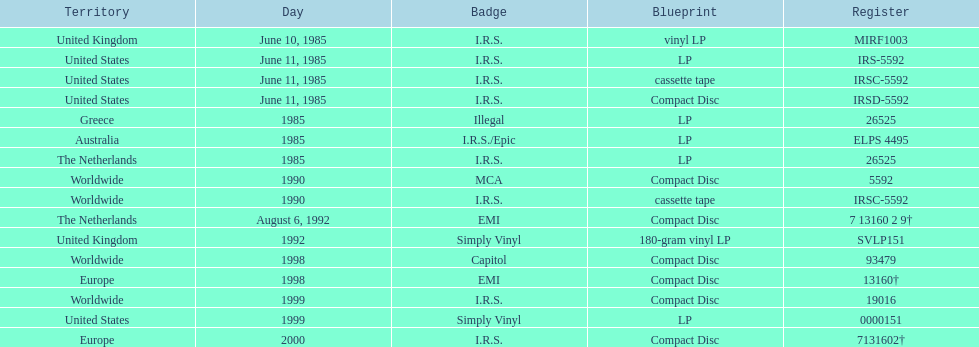Which is the only region with vinyl lp format? United Kingdom. Can you give me this table as a dict? {'header': ['Territory', 'Day', 'Badge', 'Blueprint', 'Register'], 'rows': [['United Kingdom', 'June 10, 1985', 'I.R.S.', 'vinyl LP', 'MIRF1003'], ['United States', 'June 11, 1985', 'I.R.S.', 'LP', 'IRS-5592'], ['United States', 'June 11, 1985', 'I.R.S.', 'cassette tape', 'IRSC-5592'], ['United States', 'June 11, 1985', 'I.R.S.', 'Compact Disc', 'IRSD-5592'], ['Greece', '1985', 'Illegal', 'LP', '26525'], ['Australia', '1985', 'I.R.S./Epic', 'LP', 'ELPS 4495'], ['The Netherlands', '1985', 'I.R.S.', 'LP', '26525'], ['Worldwide', '1990', 'MCA', 'Compact Disc', '5592'], ['Worldwide', '1990', 'I.R.S.', 'cassette tape', 'IRSC-5592'], ['The Netherlands', 'August 6, 1992', 'EMI', 'Compact Disc', '7 13160 2 9†'], ['United Kingdom', '1992', 'Simply Vinyl', '180-gram vinyl LP', 'SVLP151'], ['Worldwide', '1998', 'Capitol', 'Compact Disc', '93479'], ['Europe', '1998', 'EMI', 'Compact Disc', '13160†'], ['Worldwide', '1999', 'I.R.S.', 'Compact Disc', '19016'], ['United States', '1999', 'Simply Vinyl', 'LP', '0000151'], ['Europe', '2000', 'I.R.S.', 'Compact Disc', '7131602†']]} 